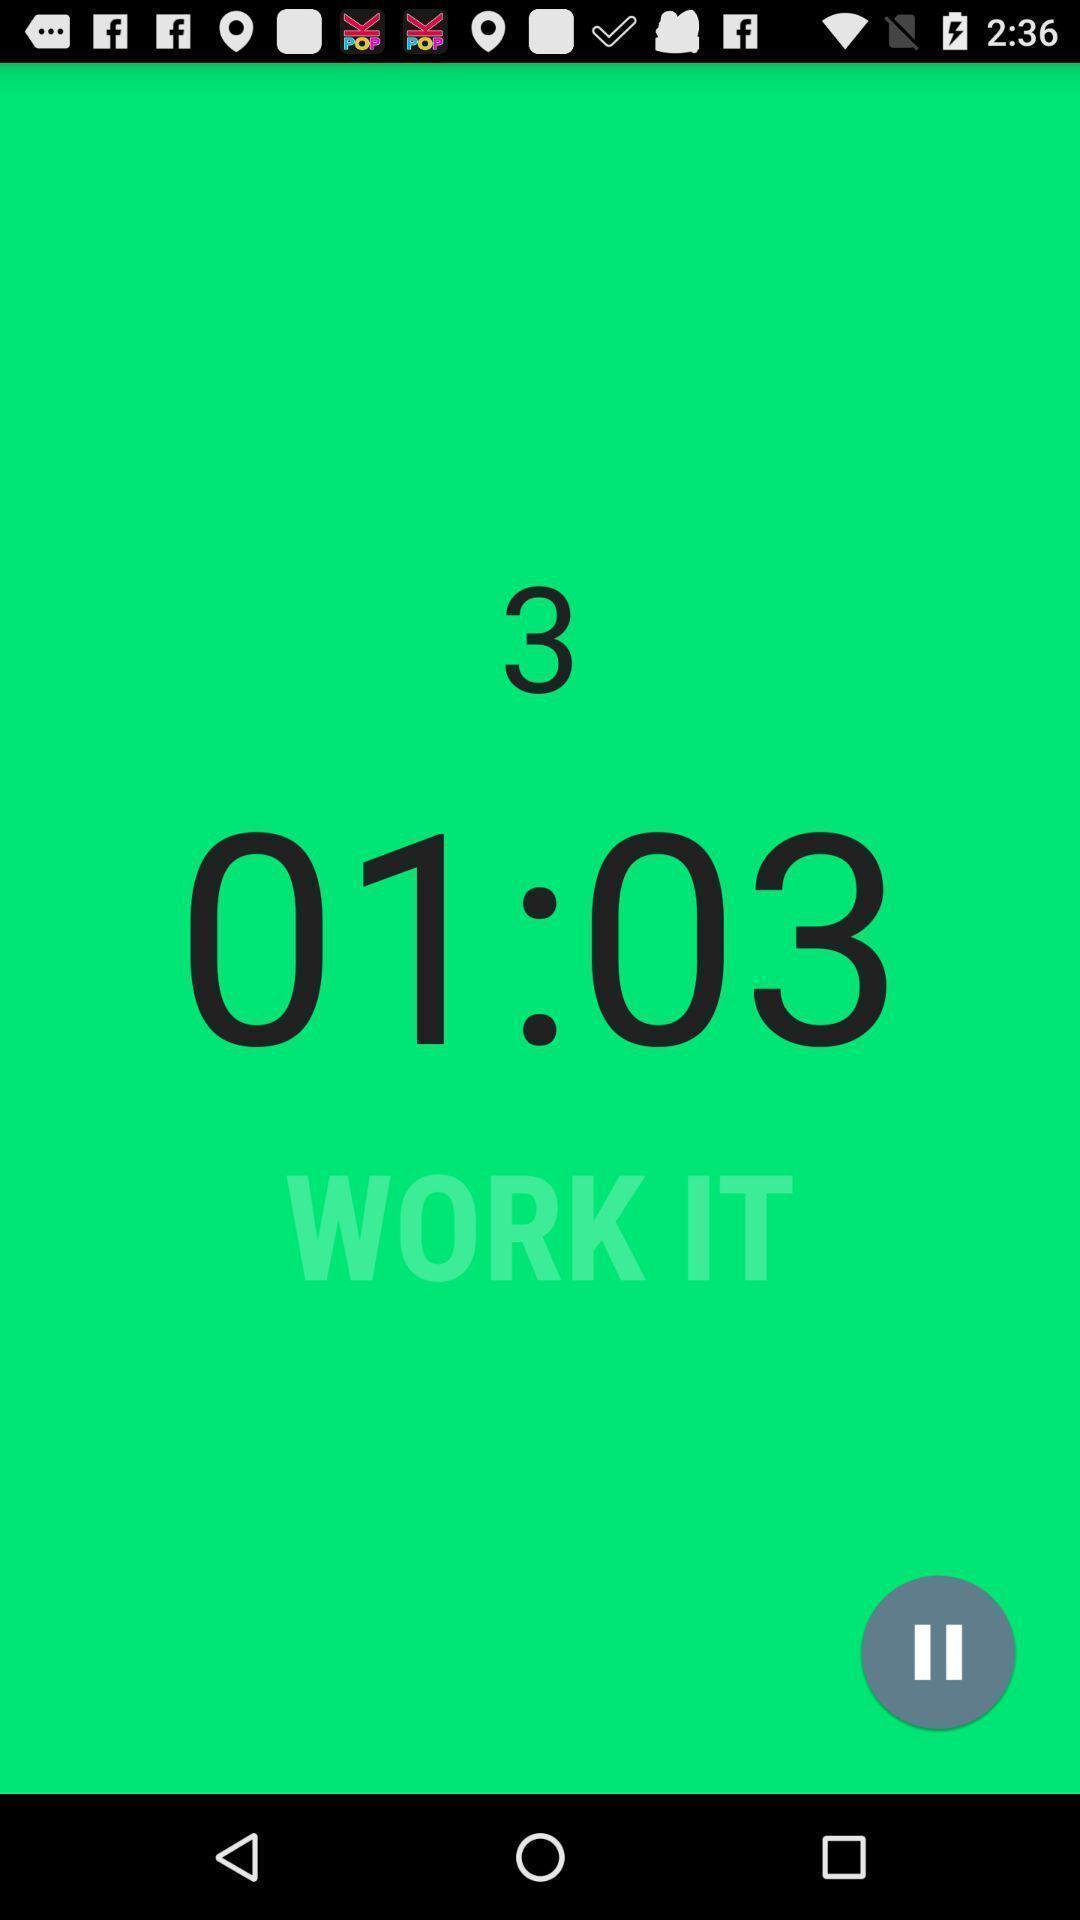Please provide a description for this image. Time details are displaying in timer app. 